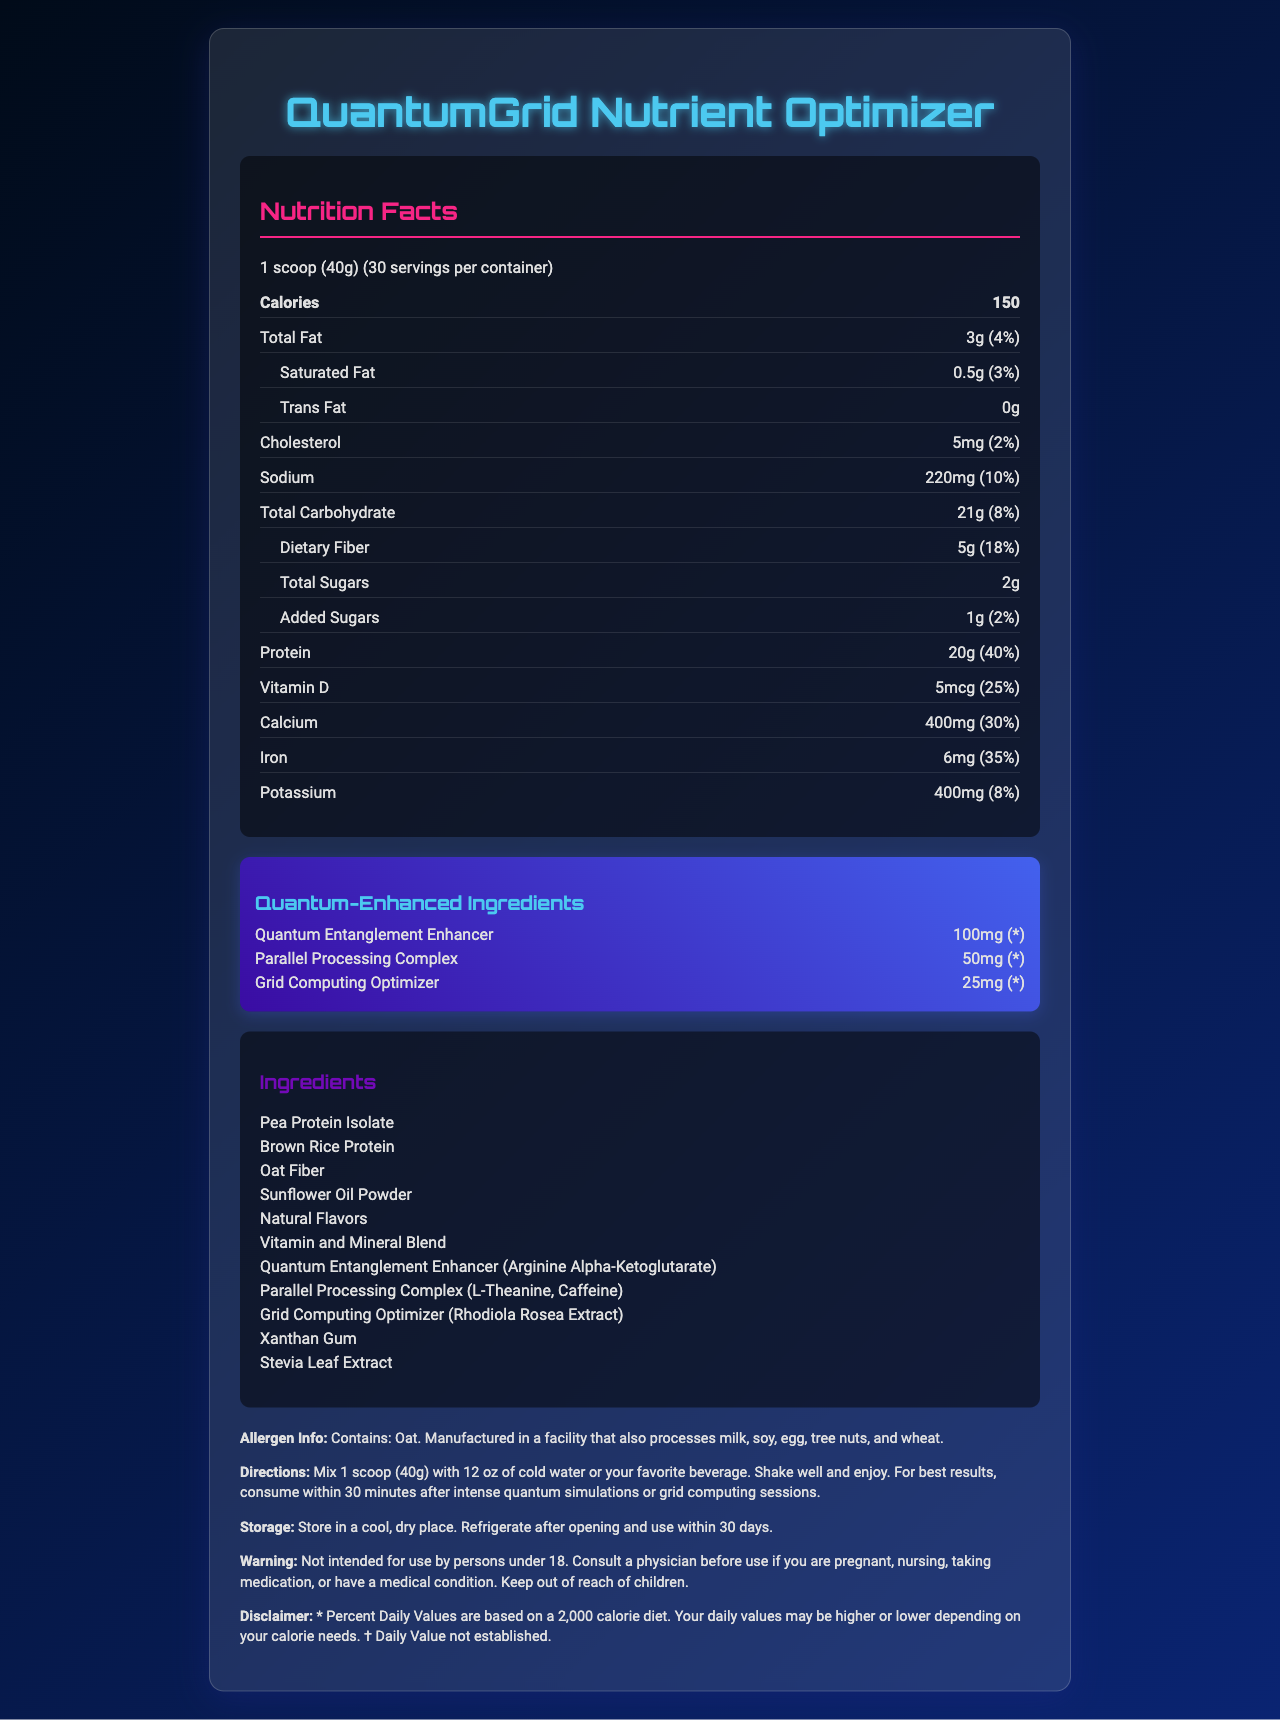what is the serving size? The serving size is mentioned at the top of the nutrition facts section as "1 scoop (40g)".
Answer: 1 scoop (40g) how many servings are in each container? The number of servings per container is provided next to the serving size information.
Answer: 30 servings how many calories are in one serving? The calorie content per serving is stated right under the serving size information in the Nutrition Facts section.
Answer: 150 calories how much total fat is in one serving? The total fat content is broken down in the Nutrition Facts, indicated as "3g" and "4% of the daily value (DV)".
Answer: 3g (4% DV) what is the amount of dietary fiber per serving? The dietary fiber content is listed under the total carbohydrate section as "5g" and "18% DV".
Answer: 5g (18% DV) how much protein does one scoop contain? The amount of protein per serving is provided in the Nutrition Facts as "20g" and "40% DV".
Answer: 20g (40% DV) what is the amount of Vitamin C in each serving? A. 30mg B. 45mg C. 60mg D. 100mg Vitamin C content is listed in the nutrition facts as "60mg" with a daily value of "70%".
Answer: C. 60mg which two ingredients are part of the Parallel Processing Complex? 1. L-Theanine 2. Caffeine 3. Rhodiola Rosea Extract 4. Xanthan Gum The Parallel Processing Complex includes L-Theanine and Caffeine according to the ingredients list.
Answer: 1 and 2 does this product contain milk or soy? The allergen information states it is manufactured in a facility that processes milk and soy, but it does not specify if it directly contains these allergens.
Answer: Cannot be determined summarize the main idea of the document This document describes the nutritional components, ingredients, and special complexes in QuantumGrid Nutrient Optimizer, a meal replacement shake intended to support cognitive and physical performance during intense computational activities. It provides detailed information on dietary values, ingredients, and usage instructions.
Answer: QuantumGrid Nutrient Optimizer is a meal replacement shake designed for those engaged in quantum simulations and grid computing. It provides a comprehensive nutritional profile with high protein, vitamins, and unique ingredients for enhanced cognitive functions. 